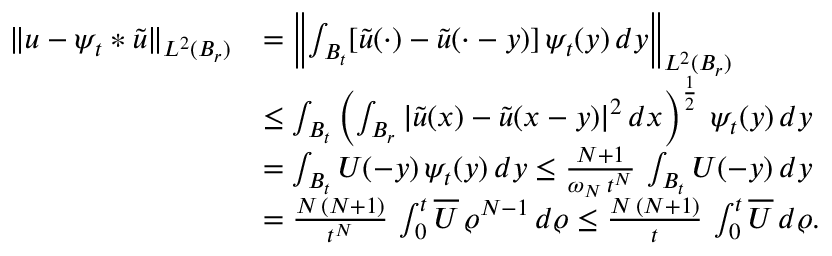Convert formula to latex. <formula><loc_0><loc_0><loc_500><loc_500>\begin{array} { r l } { \| u - \psi _ { t } \ast \widetilde { u } \| _ { L ^ { 2 } ( B _ { r } ) } } & { = \left \| \int _ { B _ { t } } [ \widetilde { u } ( \cdot ) - \widetilde { u } ( \cdot - y ) ] \, \psi _ { t } ( y ) \, d y \right \| _ { L ^ { 2 } ( B _ { r } ) } } \\ & { \leq \int _ { B _ { t } } \left ( \int _ { B _ { r } } | \widetilde { u } ( x ) - \widetilde { u } ( x - y ) | ^ { 2 } \, d x \right ) ^ { \frac { 1 } { 2 } } \, \psi _ { t } ( y ) \, d y } \\ & { = \int _ { B _ { t } } U ( - y ) \, \psi _ { t } ( y ) \, d y \leq \frac { N + 1 } { \omega _ { N } \, t ^ { N } } \, \int _ { B _ { t } } U ( - y ) \, d y } \\ & { = \frac { N \, ( N + 1 ) } { t ^ { N } } \, \int _ { 0 } ^ { t } \overline { U } \, \varrho ^ { N - 1 } \, d \varrho \leq \frac { N \, ( N + 1 ) } { t } \, \int _ { 0 } ^ { t } \overline { U } \, d \varrho . } \end{array}</formula> 